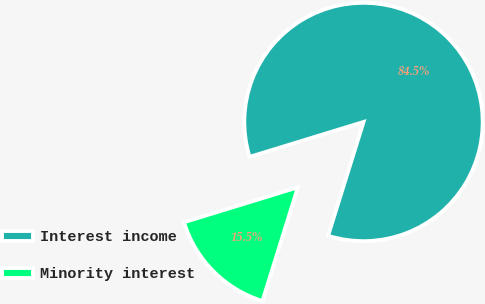<chart> <loc_0><loc_0><loc_500><loc_500><pie_chart><fcel>Interest income<fcel>Minority interest<nl><fcel>84.54%<fcel>15.46%<nl></chart> 